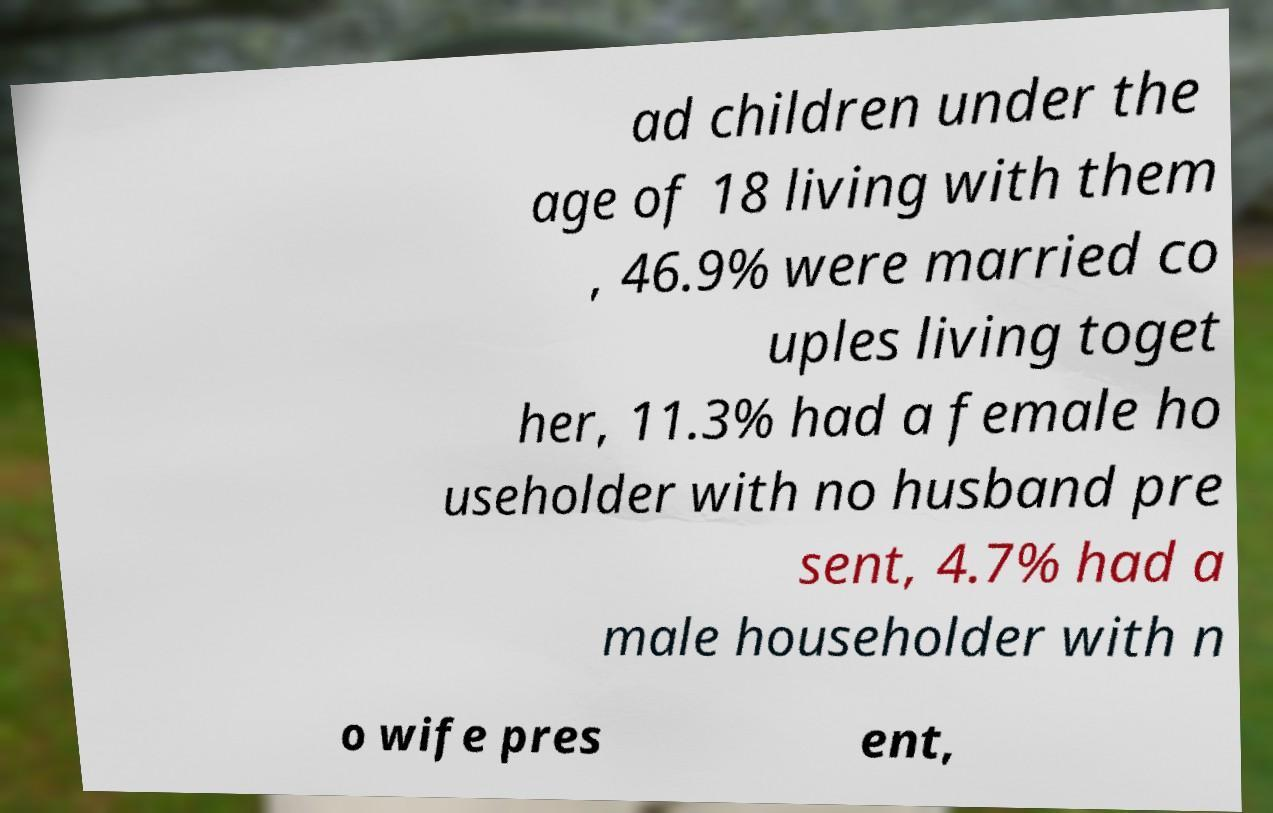Could you extract and type out the text from this image? ad children under the age of 18 living with them , 46.9% were married co uples living toget her, 11.3% had a female ho useholder with no husband pre sent, 4.7% had a male householder with n o wife pres ent, 